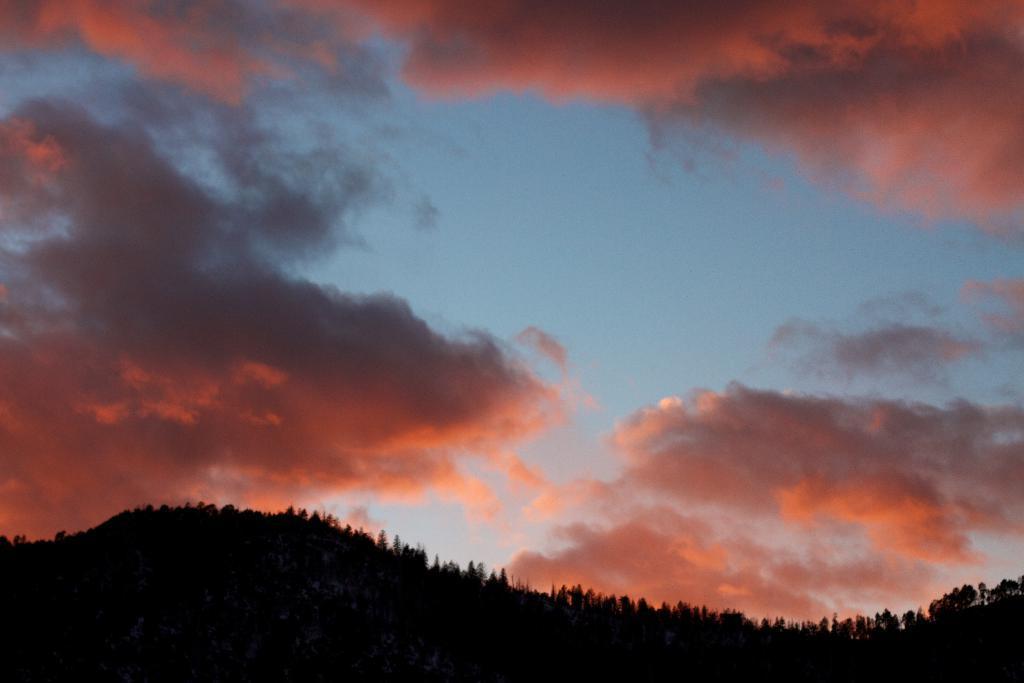In one or two sentences, can you explain what this image depicts? In the image there is mountain in the front covered with trees all over it and above its sky covered with red clouds. 